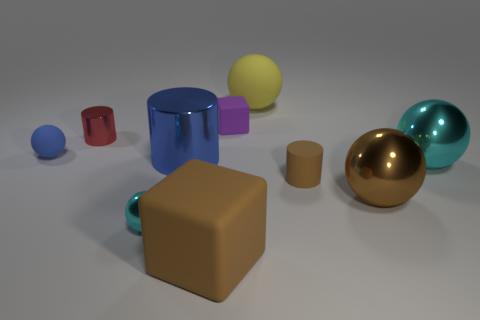Subtract all small cylinders. How many cylinders are left? 1 Subtract all blue cylinders. How many cyan spheres are left? 2 Subtract all cyan balls. How many balls are left? 3 Subtract 1 spheres. How many spheres are left? 4 Subtract all cubes. How many objects are left? 8 Subtract all cyan balls. Subtract all red cylinders. How many balls are left? 3 Add 7 big blue objects. How many big blue objects exist? 8 Subtract 0 yellow blocks. How many objects are left? 10 Subtract all large metal cylinders. Subtract all tiny red metal cylinders. How many objects are left? 8 Add 3 big blue objects. How many big blue objects are left? 4 